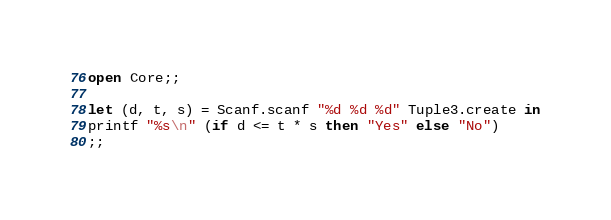Convert code to text. <code><loc_0><loc_0><loc_500><loc_500><_OCaml_>open Core;;

let (d, t, s) = Scanf.scanf "%d %d %d" Tuple3.create in
printf "%s\n" (if d <= t * s then "Yes" else "No")
;;

</code> 